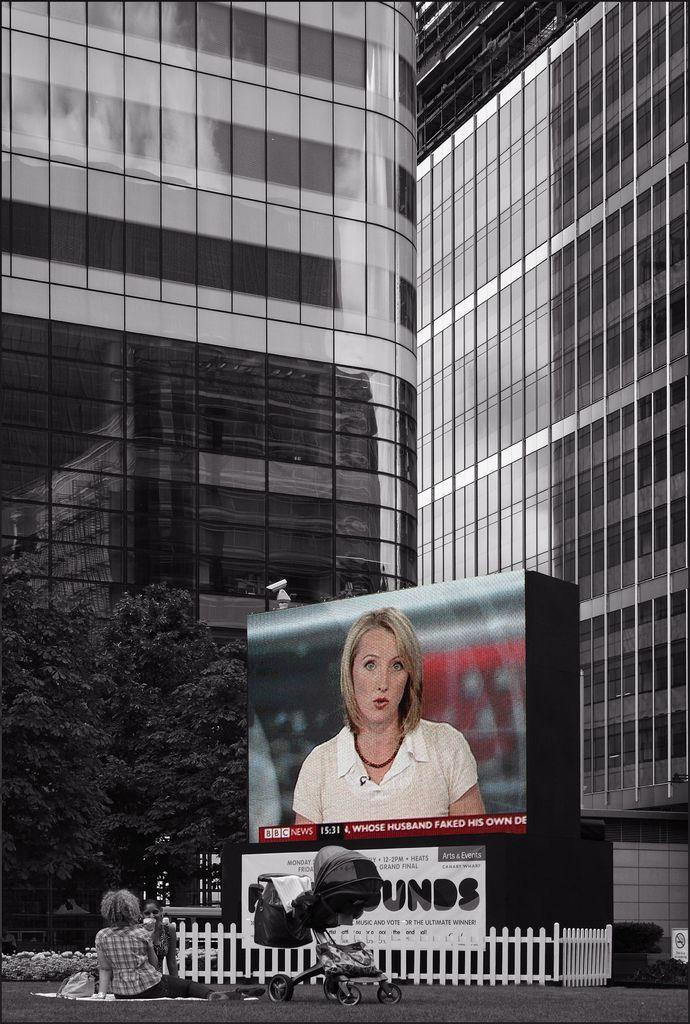Describe this image in one or two sentences. In the image we can see there are people sitting on the ground and beside them there is a buggy. Behind there is a big tv screen and there is a building. There are trees in the area. 